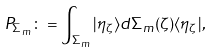Convert formula to latex. <formula><loc_0><loc_0><loc_500><loc_500>P _ { \Sigma _ { m } } \colon = \int _ { \Sigma _ { m } } | \eta _ { \zeta } \rangle d \Sigma _ { m } ( \zeta ) \langle \eta _ { \zeta } | ,</formula> 